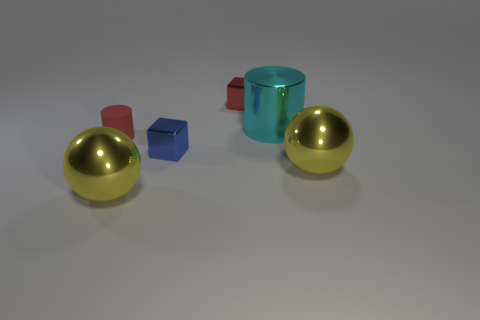There is another object that is the same color as the tiny matte object; what size is it?
Provide a short and direct response. Small. There is a metal object that is both in front of the blue thing and on the right side of the blue shiny block; what is its size?
Your answer should be compact. Large. How many small red matte cylinders are to the right of the yellow metallic object that is on the left side of the small metallic thing that is in front of the cyan metallic object?
Offer a terse response. 0. Are there any matte things of the same color as the small cylinder?
Make the answer very short. No. What is the color of the matte cylinder that is the same size as the red cube?
Your answer should be compact. Red. There is a yellow object behind the yellow ball that is in front of the yellow metallic thing right of the blue object; what shape is it?
Make the answer very short. Sphere. There is a red object that is in front of the tiny red cube; what number of tiny red matte objects are in front of it?
Ensure brevity in your answer.  0. Does the large yellow shiny object to the left of the tiny blue metal cube have the same shape as the yellow object right of the cyan cylinder?
Your answer should be compact. Yes. There is a matte thing; how many small cubes are behind it?
Your response must be concise. 1. Is the red object that is in front of the big cyan cylinder made of the same material as the tiny blue object?
Your answer should be very brief. No. 